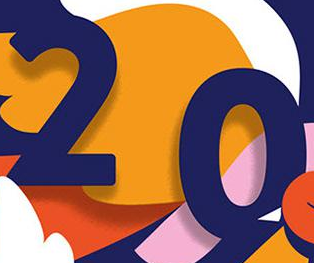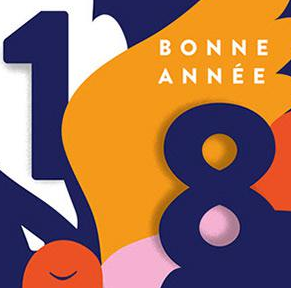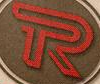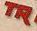Transcribe the words shown in these images in order, separated by a semicolon. 20; 18; R; TR 